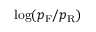<formula> <loc_0><loc_0><loc_500><loc_500>\log ( p _ { F } / p _ { R } )</formula> 